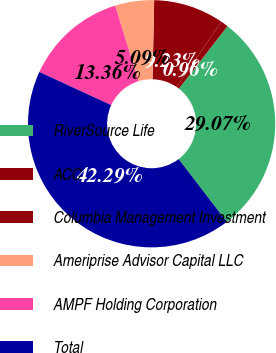Convert chart. <chart><loc_0><loc_0><loc_500><loc_500><pie_chart><fcel>RiverSource Life<fcel>ACC<fcel>Columbia Management Investment<fcel>Ameriprise Advisor Capital LLC<fcel>AMPF Holding Corporation<fcel>Total<nl><fcel>29.07%<fcel>0.96%<fcel>9.23%<fcel>5.09%<fcel>13.36%<fcel>42.29%<nl></chart> 